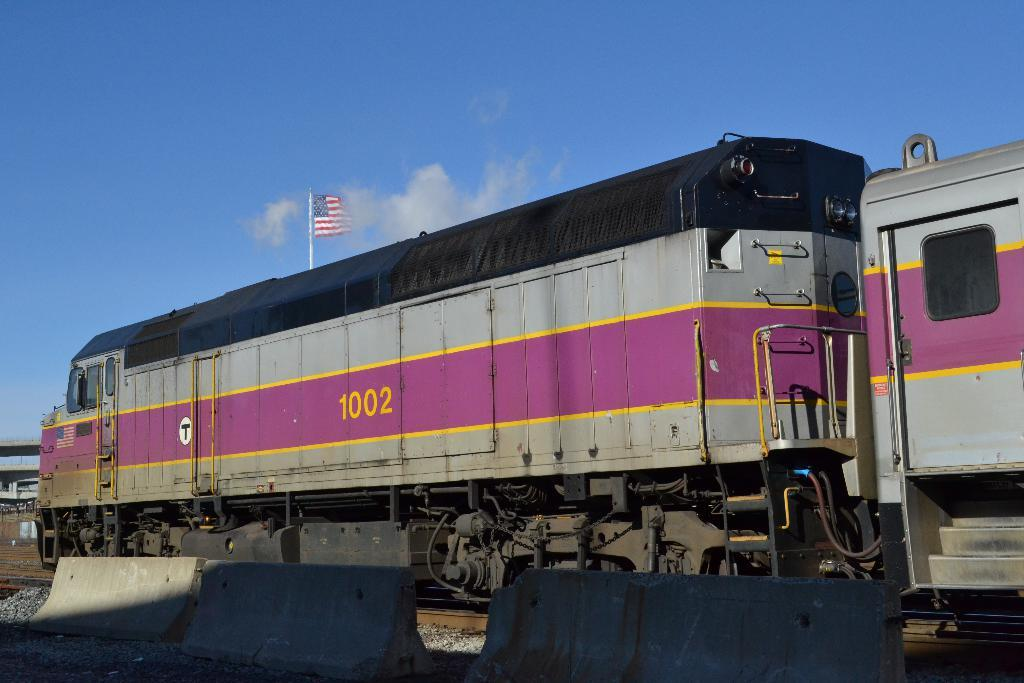What is the main subject of the image? The main subject of the image is a train. Can you describe the train's location in the image? The train is on a track in the image. What is present next to the train? There are dividers next to the train. What can be seen in the background of the image? There is a flag visible in the background, and the sky is also visible. What is the condition of the sky in the image? The sky has clouds in it, and it is visible in the background. What type of grass can be seen growing on the train in the image? There is no grass growing on the train in the image. How much wealth is visible in the image? There is no indication of wealth in the image; it features a train on a track with dividers and a background with a flag and clouds. 